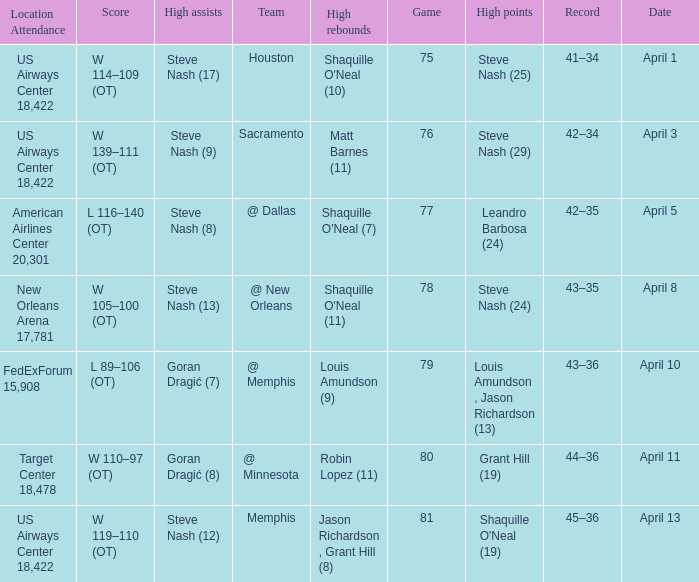What was the team's score on April 1? W 114–109 (OT). 